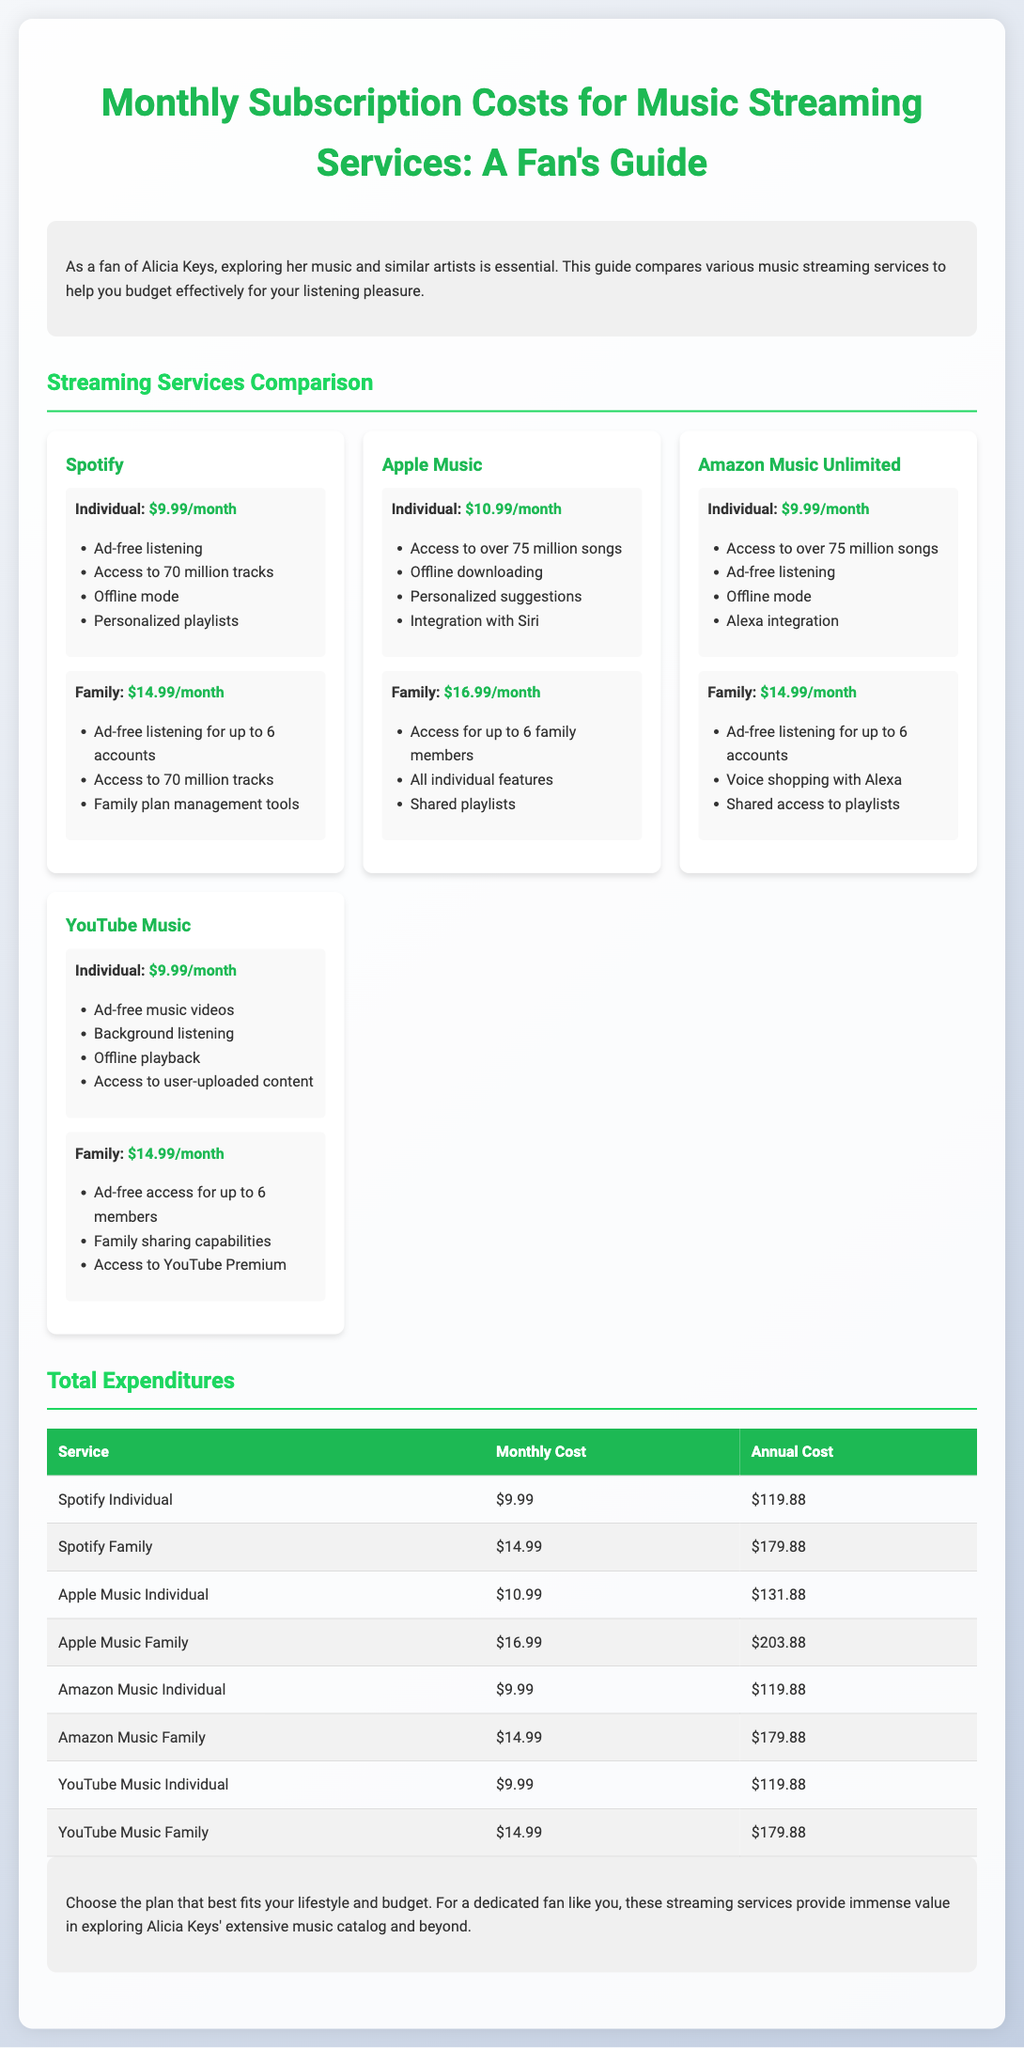What is the monthly cost of Spotify's Individual plan? The document states that Spotify's Individual plan costs $9.99 per month.
Answer: $9.99 How many songs does Apple Music offer access to? The document indicates that Apple Music offers access to over 75 million songs.
Answer: 75 million What is the family monthly cost for YouTube Music? The document provides the family monthly cost for YouTube Music, which is $14.99.
Answer: $14.99 What is the total annual cost of Amazon Music Individual plan? The document shows that the annual cost for Amazon Music's Individual plan is $119.88.
Answer: $119.88 How does the cost of the Family plan for Spotify compare to Apple Music? The document states that Spotify's Family plan costs $14.99, while Apple Music's Family plan costs $16.99, making Spotify's plan cheaper.
Answer: Cheaper What feature does Spotify and Amazon Music both offer? Both services provide ad-free listening according to the document.
Answer: Ad-free listening How many family members can share the Apple Music Family plan? The document indicates that up to 6 family members can share the Apple Music Family plan.
Answer: 6 Which streaming service has a monthly cost of $9.99 that also offers offline mode? The document lists both Spotify and Amazon Music Unlimited as services that have this cost and feature.
Answer: Spotify and Amazon Music Unlimited What is the purpose of this document? The document serves to compare various music streaming services to aid fans of Alicia Keys in budgeting for their music subscriptions.
Answer: Budgeting for music subscriptions 